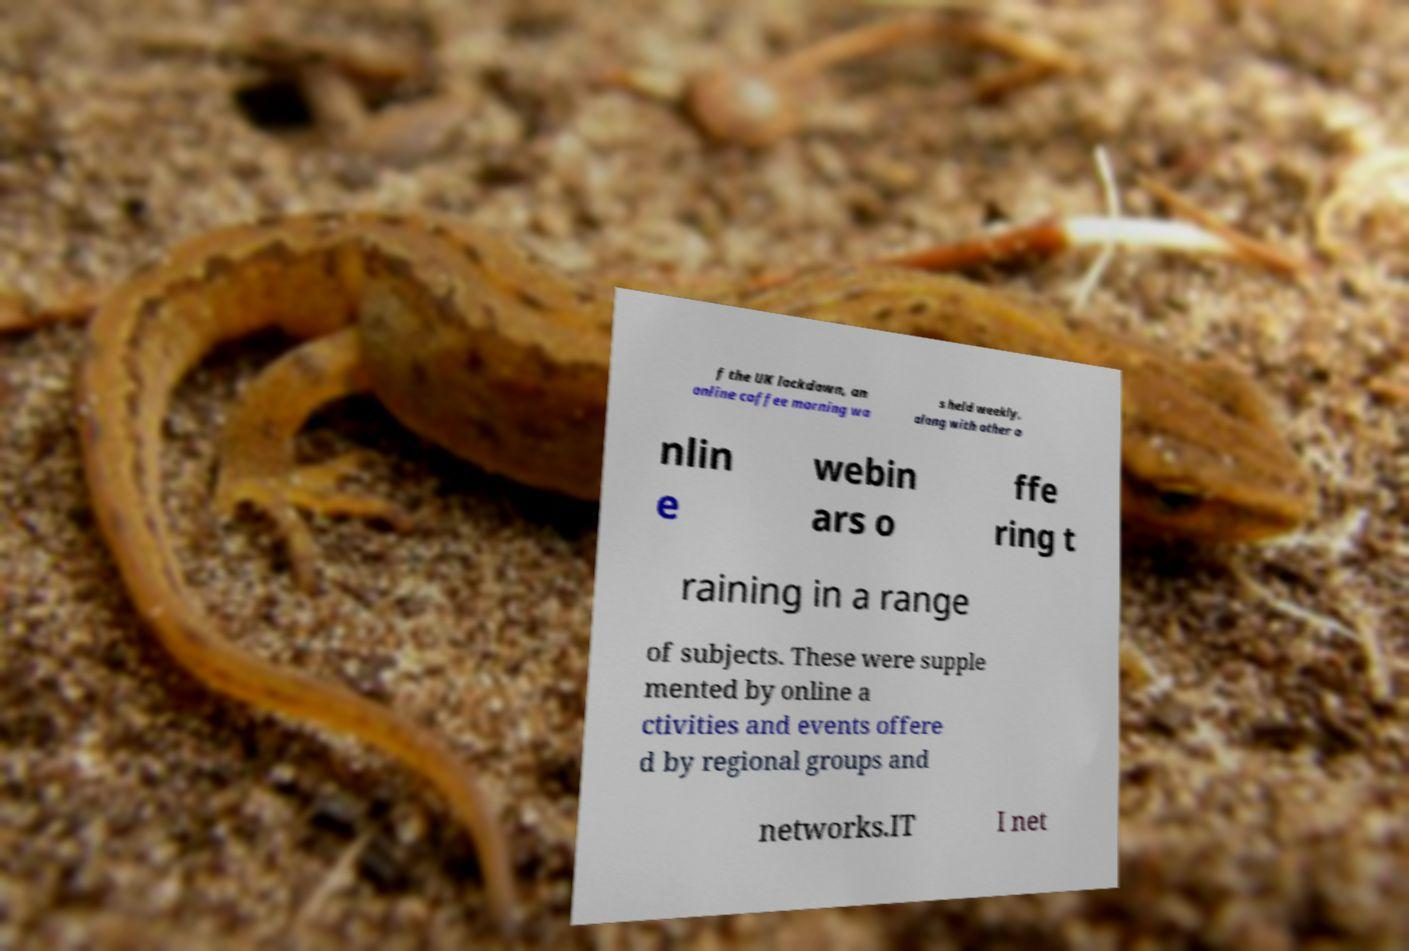There's text embedded in this image that I need extracted. Can you transcribe it verbatim? f the UK lockdown, an online coffee morning wa s held weekly, along with other o nlin e webin ars o ffe ring t raining in a range of subjects. These were supple mented by online a ctivities and events offere d by regional groups and networks.IT I net 